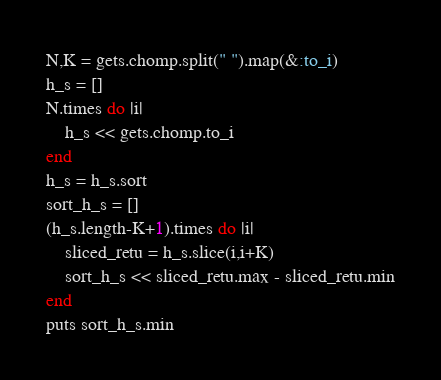Convert code to text. <code><loc_0><loc_0><loc_500><loc_500><_Ruby_>N,K = gets.chomp.split(" ").map(&:to_i)
h_s = []
N.times do |i|
    h_s << gets.chomp.to_i
end
h_s = h_s.sort
sort_h_s = []
(h_s.length-K+1).times do |i|
    sliced_retu = h_s.slice(i,i+K)
    sort_h_s << sliced_retu.max - sliced_retu.min
end
puts sort_h_s.min
</code> 